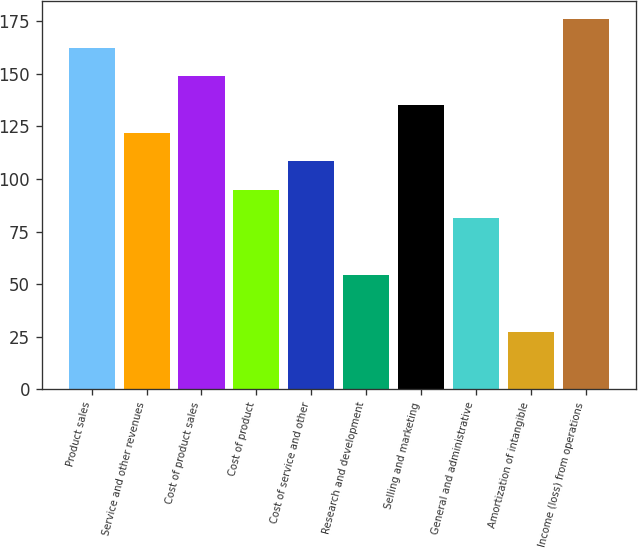<chart> <loc_0><loc_0><loc_500><loc_500><bar_chart><fcel>Product sales<fcel>Service and other revenues<fcel>Cost of product sales<fcel>Cost of product<fcel>Cost of service and other<fcel>Research and development<fcel>Selling and marketing<fcel>General and administrative<fcel>Amortization of intangible<fcel>Income (loss) from operations<nl><fcel>162.46<fcel>121.87<fcel>148.93<fcel>94.81<fcel>108.34<fcel>54.22<fcel>135.4<fcel>81.28<fcel>27.16<fcel>175.99<nl></chart> 